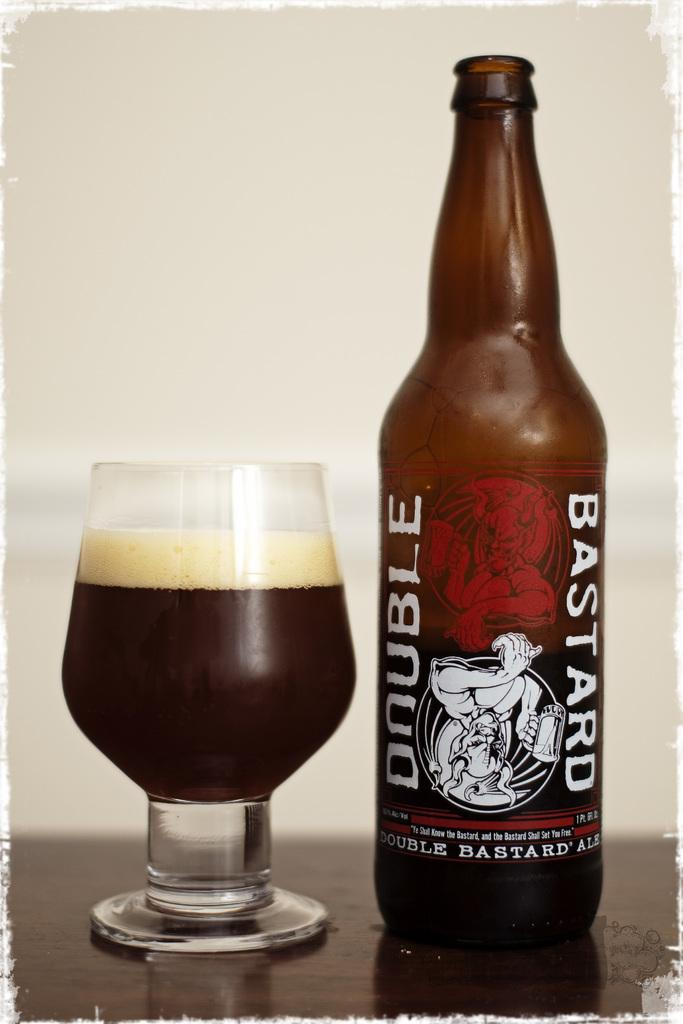<image>
Present a compact description of the photo's key features. A bottle of double bastard ale that has been poured in a glass. 